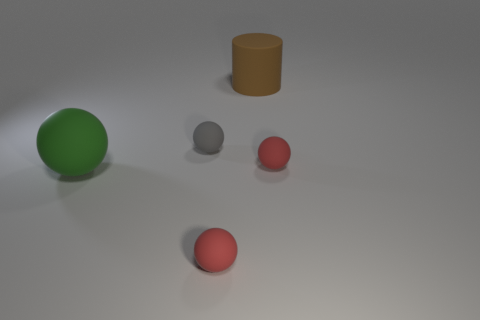What number of spheres are either small gray things or brown things?
Your answer should be very brief. 1. What number of tiny spheres are there?
Offer a terse response. 3. There is a gray matte thing; is it the same shape as the matte thing in front of the big green rubber object?
Offer a terse response. Yes. What number of objects are green matte spheres or red things?
Offer a terse response. 3. There is a big rubber object behind the large matte thing left of the brown matte thing; what shape is it?
Give a very brief answer. Cylinder. Do the large matte thing behind the gray sphere and the gray matte object have the same shape?
Your response must be concise. No. What is the size of the brown cylinder that is made of the same material as the large sphere?
Make the answer very short. Large. What number of objects are red matte things that are to the right of the green ball or rubber objects on the right side of the large green thing?
Your answer should be very brief. 4. Are there an equal number of big balls on the right side of the large green object and green balls that are to the right of the large brown object?
Ensure brevity in your answer.  Yes. The thing behind the tiny gray matte sphere is what color?
Offer a very short reply. Brown. 